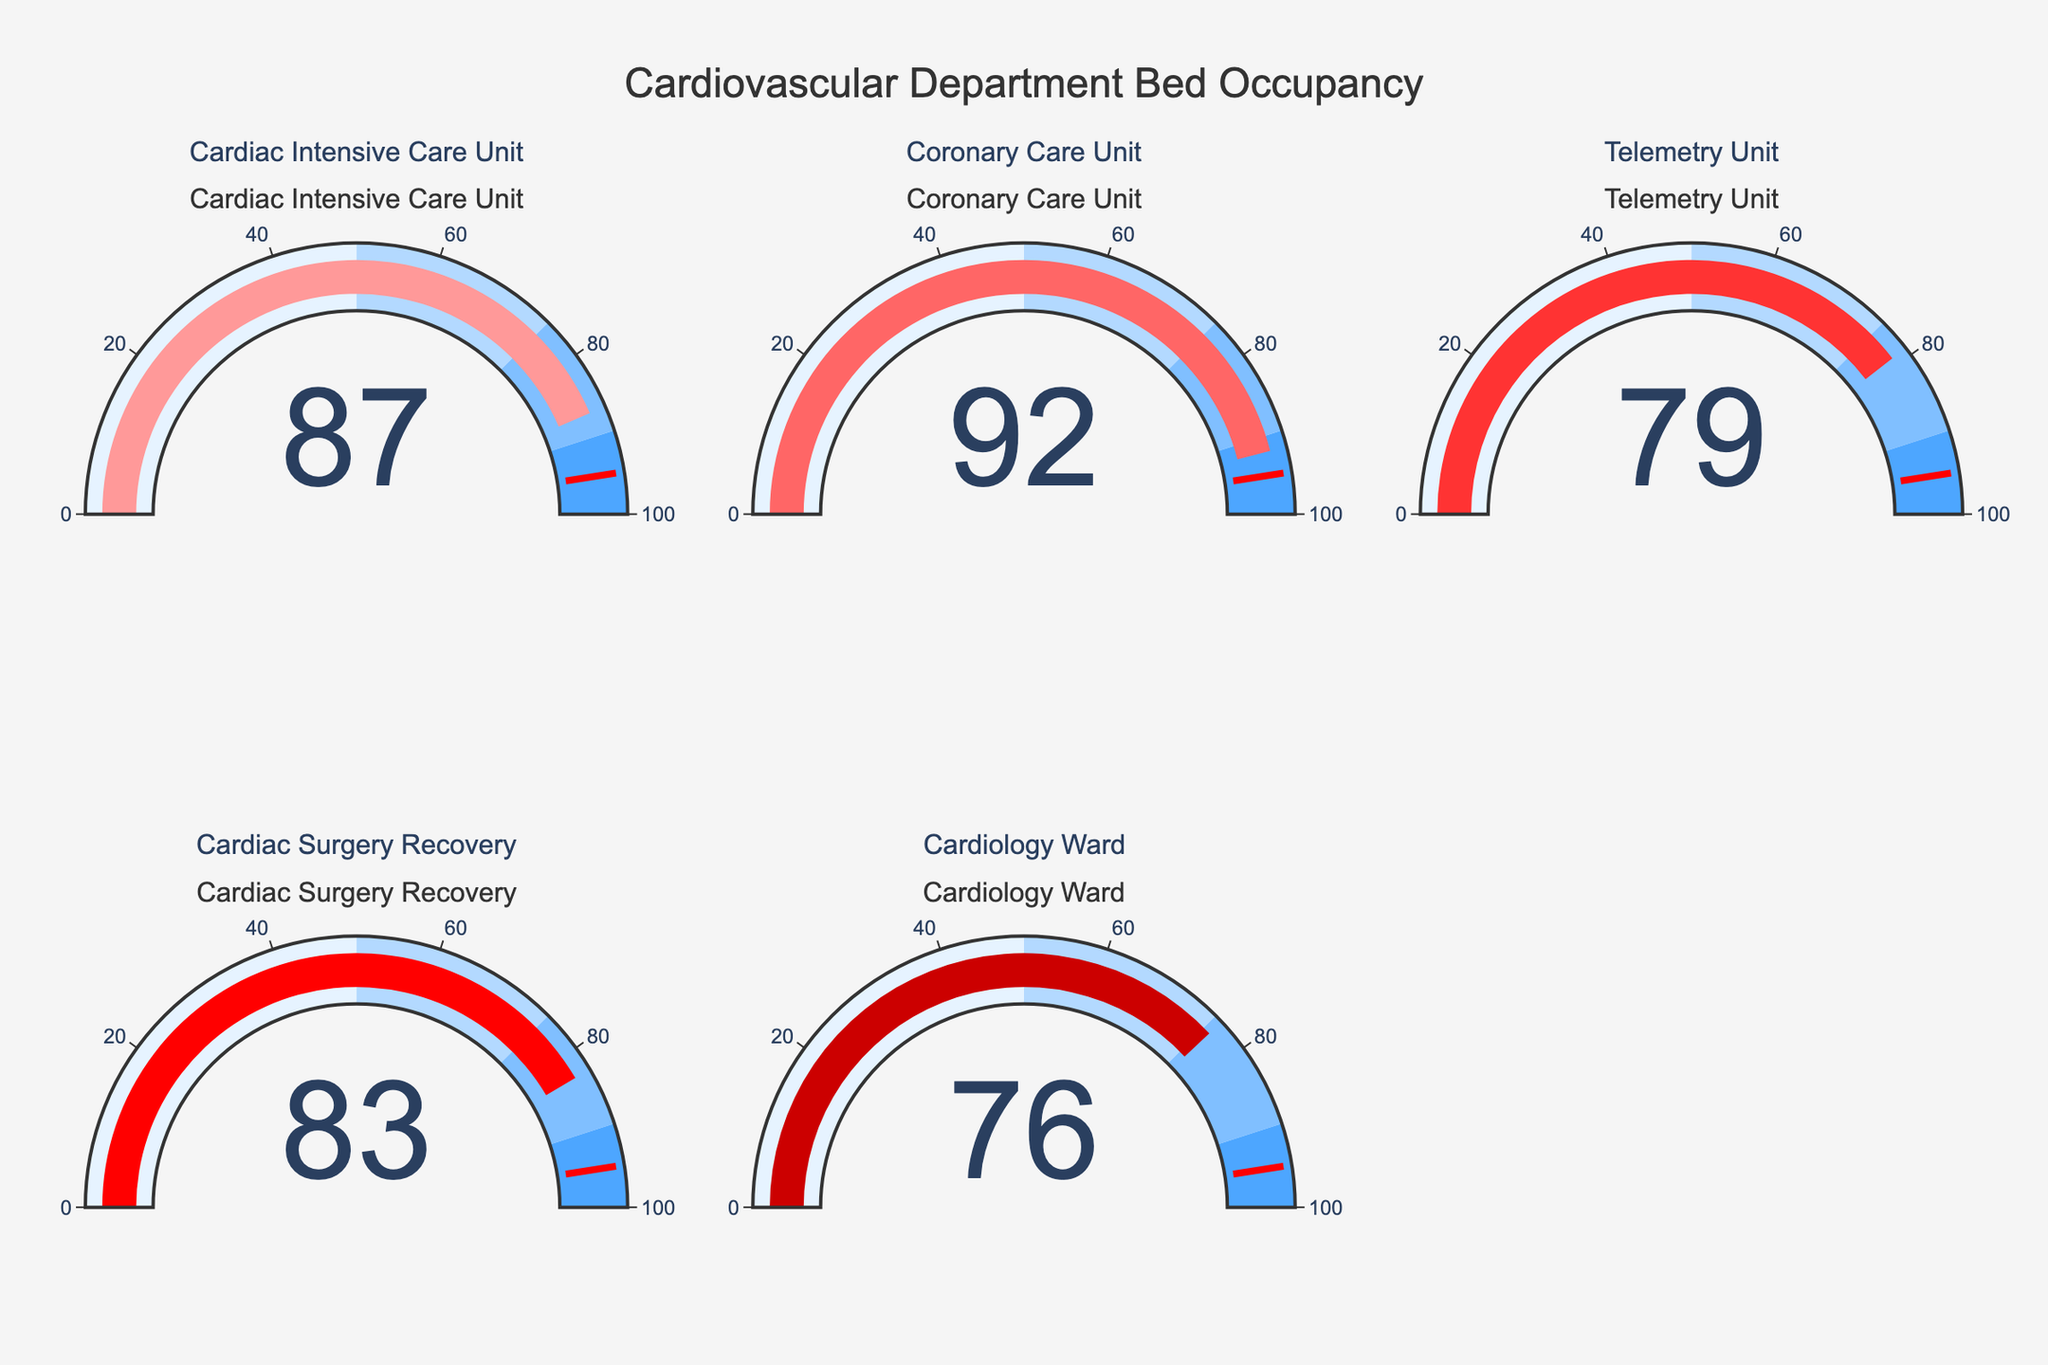How many different departments are shown in the figure? The figure includes a gauge chart for each department. By counting the number of gauge charts, we can determine how many departments are shown.
Answer: 5 What is the title of the figure? The title of the figure is displayed at the top and reads as the main heading of the chart.
Answer: Cardiovascular Department Bed Occupancy Which department has the highest occupancy rate? Look at the value displayed on each gauge. The Coronary Care Unit has the highest value among them.
Answer: Coronary Care Unit What is the average occupancy rate across all departments? Sum the occupancy rates of all departments and divide by the number of departments: (87 + 92 + 79 + 83 + 76) / 5 = 83.4
Answer: 83.4 Which departments have an occupancy rate above 80%? Look at the occupancy rates on each gauge and check which ones are above 80%. The departments are Cardiac Intensive Care Unit, Coronary Care Unit, and Cardiac Surgery Recovery.
Answer: Cardiac Intensive Care Unit, Coronary Care Unit, Cardiac Surgery Recovery What's the difference in occupancy rate between the Telemetry Unit and the Cardiac Surgery Recovery? Subtract the occupancy rate of the Telemetry Unit from the Cardiac Surgery Recovery: 83 - 79 = 4
Answer: 4 What is the color of the gauge for the department with the lowest occupancy rate? The color of the gauge indicates the department's occupancy rate. Cardiology Ward has the lowest occupancy rate (76), and its color is determined by the custom color scale used (probably a lighter red).
Answer: A lighter red Is there any department with an occupancy rate under 75%? Check each gauge for values under 75%. None of the departments have an occupancy rate under 75%.
Answer: No What is the threshold value set on the gauges? The threshold value is displayed as a red line indicator within the gauge chart.
Answer: 95 